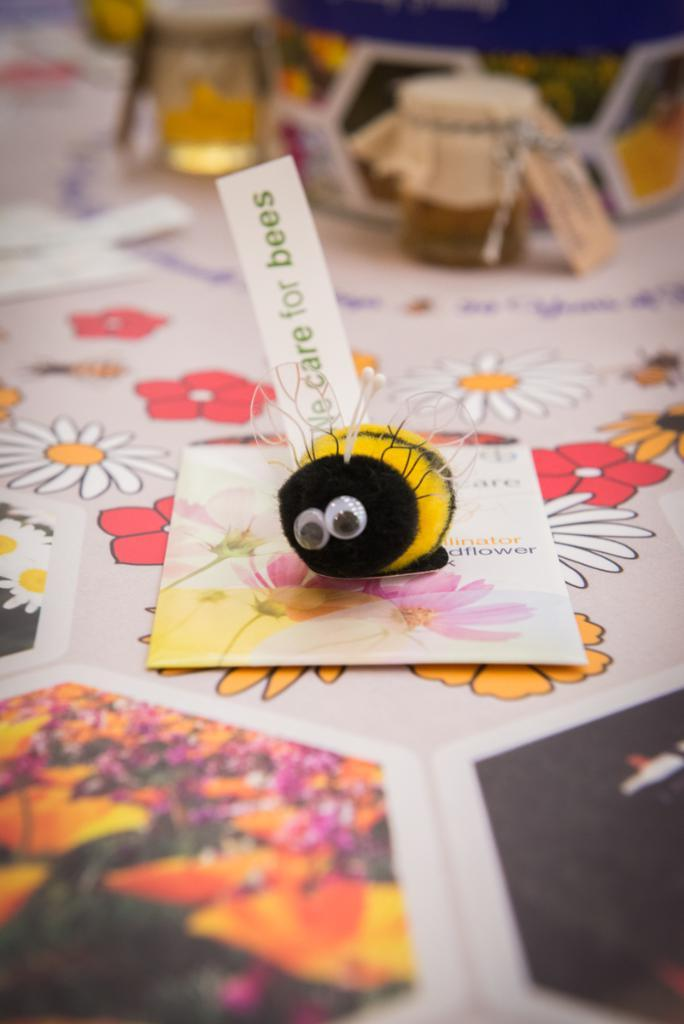<image>
Describe the image concisely. A craft made to look like a bee with a label saying "No care for bees". 